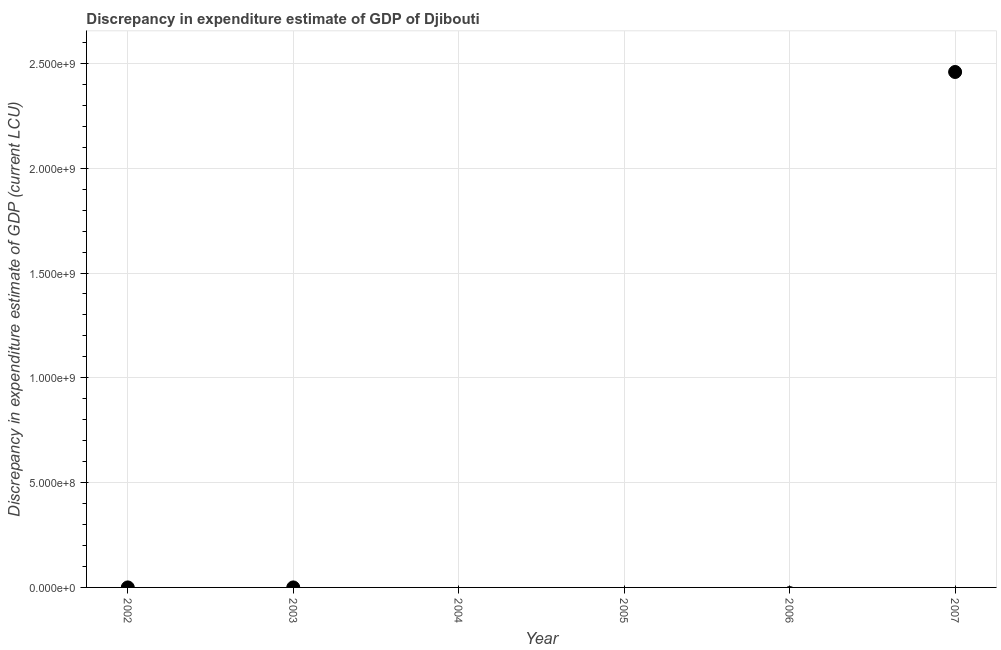What is the discrepancy in expenditure estimate of gdp in 2006?
Ensure brevity in your answer.  0. Across all years, what is the maximum discrepancy in expenditure estimate of gdp?
Your answer should be compact. 2.46e+09. In which year was the discrepancy in expenditure estimate of gdp maximum?
Your answer should be compact. 2007. What is the sum of the discrepancy in expenditure estimate of gdp?
Make the answer very short. 2.46e+09. What is the average discrepancy in expenditure estimate of gdp per year?
Ensure brevity in your answer.  4.10e+08. What is the difference between the highest and the lowest discrepancy in expenditure estimate of gdp?
Offer a very short reply. 2.46e+09. In how many years, is the discrepancy in expenditure estimate of gdp greater than the average discrepancy in expenditure estimate of gdp taken over all years?
Your answer should be compact. 1. Does the discrepancy in expenditure estimate of gdp monotonically increase over the years?
Your response must be concise. No. How many dotlines are there?
Provide a succinct answer. 1. What is the difference between two consecutive major ticks on the Y-axis?
Your answer should be very brief. 5.00e+08. Does the graph contain any zero values?
Offer a terse response. Yes. What is the title of the graph?
Offer a very short reply. Discrepancy in expenditure estimate of GDP of Djibouti. What is the label or title of the X-axis?
Provide a short and direct response. Year. What is the label or title of the Y-axis?
Provide a succinct answer. Discrepancy in expenditure estimate of GDP (current LCU). What is the Discrepancy in expenditure estimate of GDP (current LCU) in 2003?
Provide a succinct answer. 0. What is the Discrepancy in expenditure estimate of GDP (current LCU) in 2007?
Your answer should be compact. 2.46e+09. 